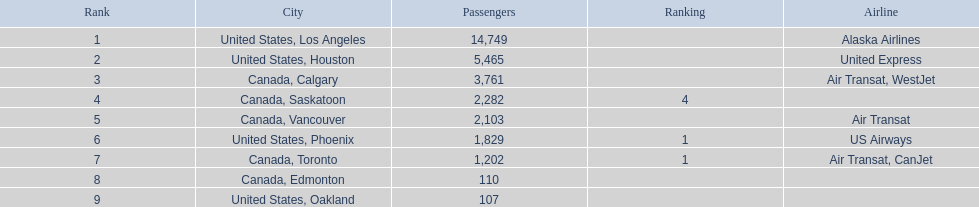What were all the passenger totals? 14,749, 5,465, 3,761, 2,282, 2,103, 1,829, 1,202, 110, 107. Which of these were to los angeles? 14,749. What other destination combined with this is closest to 19,000? Canada, Calgary. 